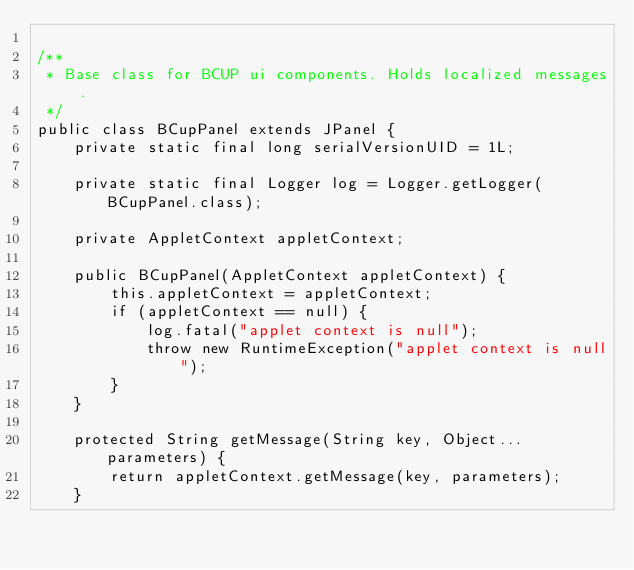<code> <loc_0><loc_0><loc_500><loc_500><_Java_>
/**
 * Base class for BCUP ui components. Holds localized messages.
 */
public class BCupPanel extends JPanel {
	private static final long serialVersionUID = 1L;
	
	private static final Logger log = Logger.getLogger(BCupPanel.class);

	private AppletContext appletContext;

	public BCupPanel(AppletContext appletContext) {
		this.appletContext = appletContext;
		if (appletContext == null) {
			log.fatal("applet context is null");
			throw new RuntimeException("applet context is null");
		}
	}

	protected String getMessage(String key, Object... parameters) {
		return appletContext.getMessage(key, parameters);
	}
</code> 